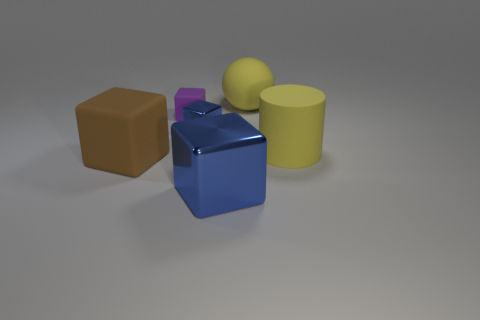Are there the same number of big rubber balls on the left side of the brown block and tiny green metal things?
Ensure brevity in your answer.  Yes. There is a rubber cylinder that is the same color as the sphere; what size is it?
Keep it short and to the point. Large. Are there any brown cubes made of the same material as the purple cube?
Give a very brief answer. Yes. There is a shiny thing that is behind the brown thing; is it the same shape as the big rubber object that is on the left side of the large rubber sphere?
Your answer should be very brief. Yes. Is there a yellow cylinder?
Ensure brevity in your answer.  Yes. There is a matte sphere that is the same size as the brown rubber object; what is its color?
Your response must be concise. Yellow. What number of other blue things are the same shape as the small blue shiny object?
Provide a succinct answer. 1. Does the blue block behind the big blue metal cube have the same material as the large blue thing?
Your answer should be very brief. Yes. What number of spheres are big blue things or purple matte things?
Offer a terse response. 0. What is the shape of the blue thing that is to the left of the big thing that is in front of the brown rubber object behind the big metal block?
Provide a short and direct response. Cube. 